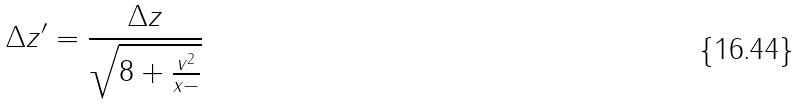<formula> <loc_0><loc_0><loc_500><loc_500>\Delta z ^ { \prime } = \frac { \Delta z } { \sqrt { 8 + \frac { v ^ { 2 } } { x - } } }</formula> 